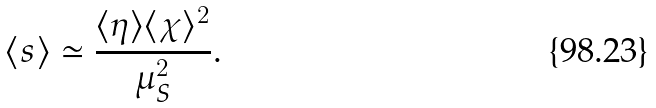Convert formula to latex. <formula><loc_0><loc_0><loc_500><loc_500>\langle s \rangle \simeq \frac { \langle \eta \rangle \langle \chi \rangle ^ { 2 } } { \mu ^ { 2 } _ { S } } .</formula> 